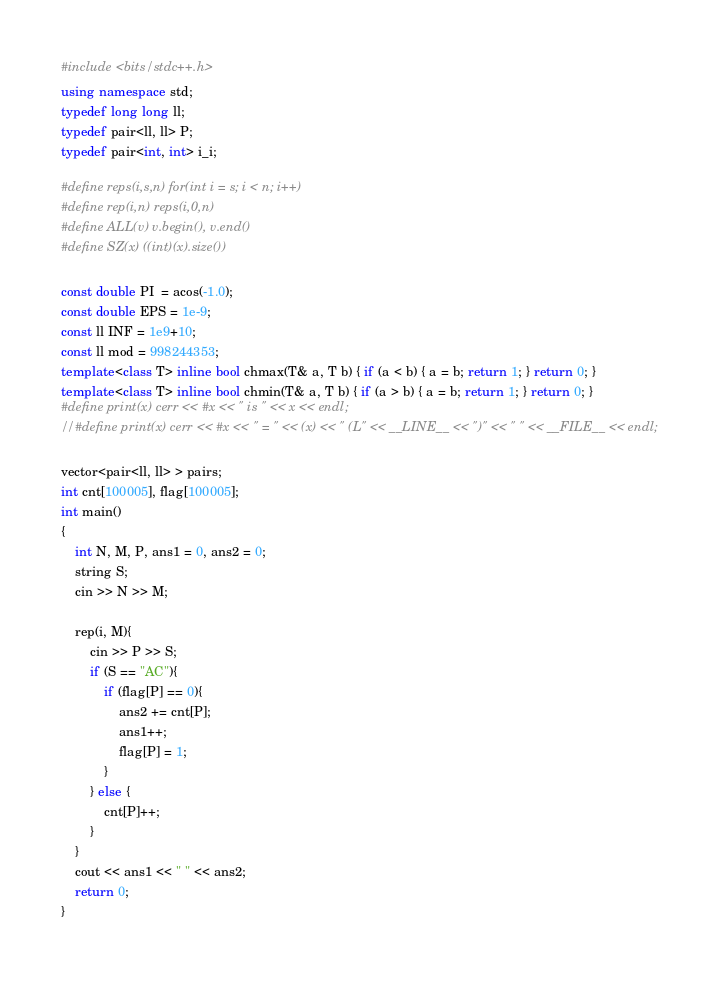<code> <loc_0><loc_0><loc_500><loc_500><_C++_>#include <bits/stdc++.h>
using namespace std;
typedef long long ll;
typedef pair<ll, ll> P;
typedef pair<int, int> i_i;

#define reps(i,s,n) for(int i = s; i < n; i++)
#define rep(i,n) reps(i,0,n)
#define ALL(v) v.begin(), v.end()
#define SZ(x) ((int)(x).size())

const double PI  = acos(-1.0);
const double EPS = 1e-9;
const ll INF = 1e9+10;
const ll mod = 998244353;
template<class T> inline bool chmax(T& a, T b) { if (a < b) { a = b; return 1; } return 0; }
template<class T> inline bool chmin(T& a, T b) { if (a > b) { a = b; return 1; } return 0; }
#define print(x) cerr << #x << " is " << x << endl;
//#define print(x) cerr << #x << " = " << (x) << " (L" << __LINE__ << ")" << " " << __FILE__ << endl; 

vector<pair<ll, ll> > pairs;
int cnt[100005], flag[100005];
int main()
{
    int N, M, P, ans1 = 0, ans2 = 0;
    string S;
    cin >> N >> M;
    
    rep(i, M){
        cin >> P >> S;
        if (S == "AC"){
            if (flag[P] == 0){
                ans2 += cnt[P];
                ans1++;
                flag[P] = 1;
            }
        } else {
            cnt[P]++;
        }
    }
    cout << ans1 << " " << ans2;
    return 0;    
}
</code> 